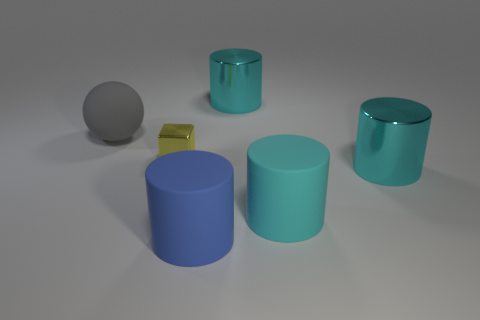Can you describe the colors of the objects in the image? Certainly! In the image, there are objects with various shades of blue and teal, a gray sphere, and a gold cube. These colors create a cool and simplistic palette. 